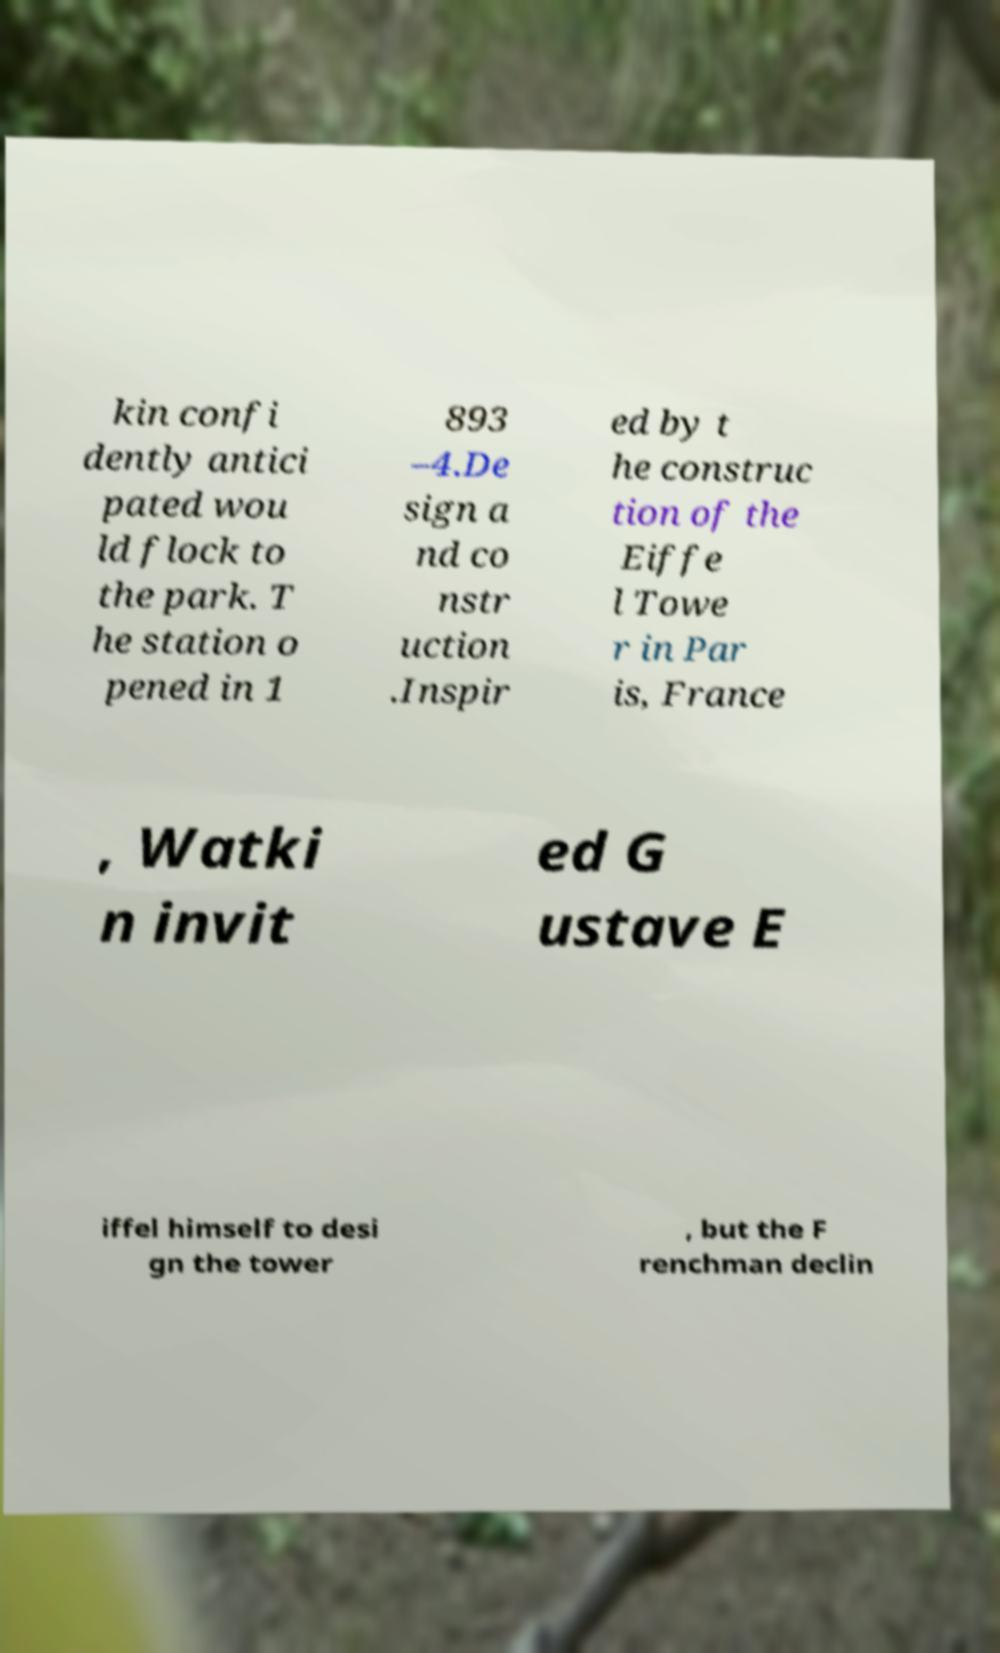Could you extract and type out the text from this image? kin confi dently antici pated wou ld flock to the park. T he station o pened in 1 893 –4.De sign a nd co nstr uction .Inspir ed by t he construc tion of the Eiffe l Towe r in Par is, France , Watki n invit ed G ustave E iffel himself to desi gn the tower , but the F renchman declin 